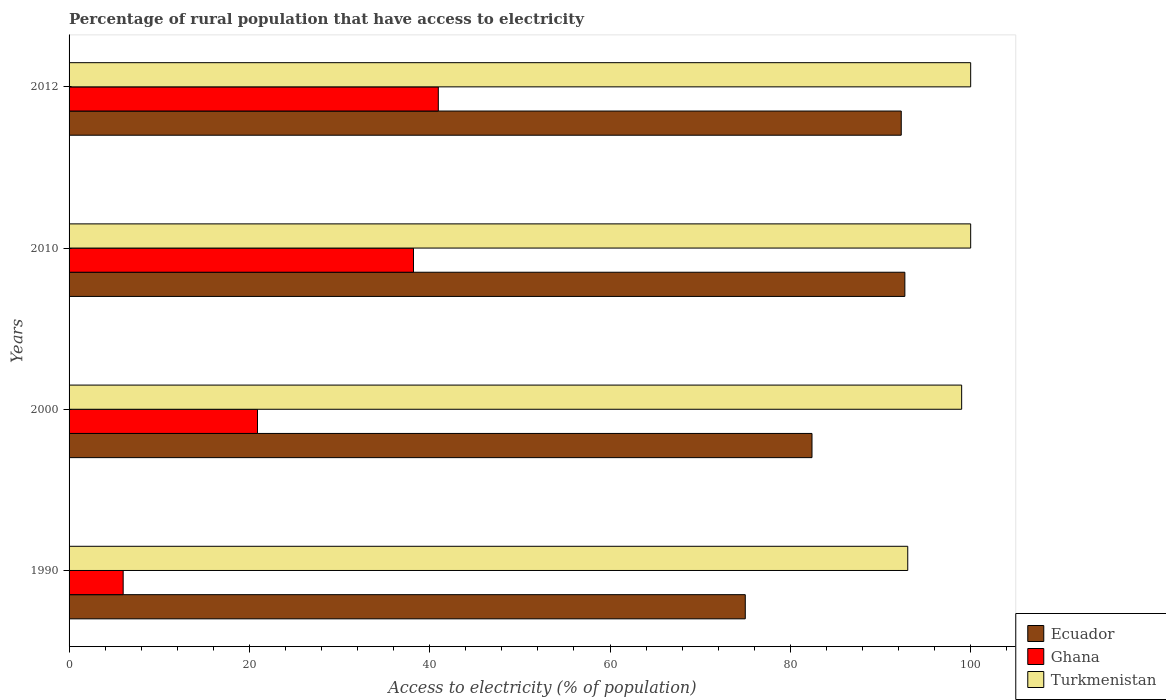How many different coloured bars are there?
Give a very brief answer. 3. How many groups of bars are there?
Provide a short and direct response. 4. Are the number of bars on each tick of the Y-axis equal?
Keep it short and to the point. Yes. What is the label of the 3rd group of bars from the top?
Give a very brief answer. 2000. In how many cases, is the number of bars for a given year not equal to the number of legend labels?
Your answer should be very brief. 0. What is the percentage of rural population that have access to electricity in Turkmenistan in 1990?
Offer a terse response. 93.02. Across all years, what is the maximum percentage of rural population that have access to electricity in Ghana?
Provide a short and direct response. 40.95. Across all years, what is the minimum percentage of rural population that have access to electricity in Ecuador?
Give a very brief answer. 75. In which year was the percentage of rural population that have access to electricity in Ghana maximum?
Provide a succinct answer. 2012. In which year was the percentage of rural population that have access to electricity in Turkmenistan minimum?
Your answer should be very brief. 1990. What is the total percentage of rural population that have access to electricity in Turkmenistan in the graph?
Your response must be concise. 392.02. What is the difference between the percentage of rural population that have access to electricity in Ghana in 2010 and that in 2012?
Provide a succinct answer. -2.75. What is the difference between the percentage of rural population that have access to electricity in Ghana in 2010 and the percentage of rural population that have access to electricity in Turkmenistan in 2012?
Your answer should be very brief. -61.8. What is the average percentage of rural population that have access to electricity in Ecuador per year?
Provide a succinct answer. 85.6. In the year 1990, what is the difference between the percentage of rural population that have access to electricity in Turkmenistan and percentage of rural population that have access to electricity in Ecuador?
Keep it short and to the point. 18.02. In how many years, is the percentage of rural population that have access to electricity in Ecuador greater than 88 %?
Your answer should be compact. 2. What is the ratio of the percentage of rural population that have access to electricity in Ghana in 2000 to that in 2010?
Provide a succinct answer. 0.55. Is the percentage of rural population that have access to electricity in Ghana in 1990 less than that in 2012?
Your response must be concise. Yes. What is the difference between the highest and the second highest percentage of rural population that have access to electricity in Ecuador?
Keep it short and to the point. 0.4. What is the difference between the highest and the lowest percentage of rural population that have access to electricity in Turkmenistan?
Keep it short and to the point. 6.98. Is the sum of the percentage of rural population that have access to electricity in Ecuador in 1990 and 2000 greater than the maximum percentage of rural population that have access to electricity in Turkmenistan across all years?
Offer a terse response. Yes. What does the 1st bar from the top in 2010 represents?
Your answer should be compact. Turkmenistan. What does the 2nd bar from the bottom in 2012 represents?
Your response must be concise. Ghana. Is it the case that in every year, the sum of the percentage of rural population that have access to electricity in Ghana and percentage of rural population that have access to electricity in Ecuador is greater than the percentage of rural population that have access to electricity in Turkmenistan?
Provide a succinct answer. No. How many bars are there?
Offer a terse response. 12. Are all the bars in the graph horizontal?
Keep it short and to the point. Yes. How many years are there in the graph?
Ensure brevity in your answer.  4. Are the values on the major ticks of X-axis written in scientific E-notation?
Your answer should be compact. No. Does the graph contain any zero values?
Ensure brevity in your answer.  No. How many legend labels are there?
Provide a short and direct response. 3. How are the legend labels stacked?
Offer a terse response. Vertical. What is the title of the graph?
Keep it short and to the point. Percentage of rural population that have access to electricity. Does "Bhutan" appear as one of the legend labels in the graph?
Provide a short and direct response. No. What is the label or title of the X-axis?
Offer a terse response. Access to electricity (% of population). What is the label or title of the Y-axis?
Your response must be concise. Years. What is the Access to electricity (% of population) of Ecuador in 1990?
Offer a very short reply. 75. What is the Access to electricity (% of population) of Ghana in 1990?
Offer a terse response. 6. What is the Access to electricity (% of population) of Turkmenistan in 1990?
Give a very brief answer. 93.02. What is the Access to electricity (% of population) of Ecuador in 2000?
Your answer should be very brief. 82.4. What is the Access to electricity (% of population) in Ghana in 2000?
Ensure brevity in your answer.  20.9. What is the Access to electricity (% of population) of Turkmenistan in 2000?
Your answer should be very brief. 99. What is the Access to electricity (% of population) in Ecuador in 2010?
Ensure brevity in your answer.  92.7. What is the Access to electricity (% of population) in Ghana in 2010?
Provide a short and direct response. 38.2. What is the Access to electricity (% of population) of Turkmenistan in 2010?
Give a very brief answer. 100. What is the Access to electricity (% of population) of Ecuador in 2012?
Provide a short and direct response. 92.3. What is the Access to electricity (% of population) in Ghana in 2012?
Provide a short and direct response. 40.95. What is the Access to electricity (% of population) of Turkmenistan in 2012?
Provide a succinct answer. 100. Across all years, what is the maximum Access to electricity (% of population) of Ecuador?
Ensure brevity in your answer.  92.7. Across all years, what is the maximum Access to electricity (% of population) in Ghana?
Keep it short and to the point. 40.95. Across all years, what is the maximum Access to electricity (% of population) of Turkmenistan?
Make the answer very short. 100. Across all years, what is the minimum Access to electricity (% of population) of Ghana?
Offer a very short reply. 6. Across all years, what is the minimum Access to electricity (% of population) in Turkmenistan?
Offer a very short reply. 93.02. What is the total Access to electricity (% of population) in Ecuador in the graph?
Provide a short and direct response. 342.4. What is the total Access to electricity (% of population) in Ghana in the graph?
Provide a succinct answer. 106.05. What is the total Access to electricity (% of population) in Turkmenistan in the graph?
Your answer should be compact. 392.02. What is the difference between the Access to electricity (% of population) of Ecuador in 1990 and that in 2000?
Make the answer very short. -7.4. What is the difference between the Access to electricity (% of population) of Ghana in 1990 and that in 2000?
Give a very brief answer. -14.9. What is the difference between the Access to electricity (% of population) in Turkmenistan in 1990 and that in 2000?
Give a very brief answer. -5.98. What is the difference between the Access to electricity (% of population) in Ecuador in 1990 and that in 2010?
Your answer should be compact. -17.7. What is the difference between the Access to electricity (% of population) in Ghana in 1990 and that in 2010?
Your response must be concise. -32.2. What is the difference between the Access to electricity (% of population) in Turkmenistan in 1990 and that in 2010?
Give a very brief answer. -6.98. What is the difference between the Access to electricity (% of population) of Ecuador in 1990 and that in 2012?
Keep it short and to the point. -17.3. What is the difference between the Access to electricity (% of population) in Ghana in 1990 and that in 2012?
Your answer should be very brief. -34.95. What is the difference between the Access to electricity (% of population) of Turkmenistan in 1990 and that in 2012?
Your answer should be compact. -6.98. What is the difference between the Access to electricity (% of population) in Ecuador in 2000 and that in 2010?
Your answer should be very brief. -10.3. What is the difference between the Access to electricity (% of population) of Ghana in 2000 and that in 2010?
Provide a succinct answer. -17.3. What is the difference between the Access to electricity (% of population) in Ghana in 2000 and that in 2012?
Make the answer very short. -20.05. What is the difference between the Access to electricity (% of population) in Ghana in 2010 and that in 2012?
Your answer should be very brief. -2.75. What is the difference between the Access to electricity (% of population) of Ecuador in 1990 and the Access to electricity (% of population) of Ghana in 2000?
Provide a succinct answer. 54.1. What is the difference between the Access to electricity (% of population) of Ghana in 1990 and the Access to electricity (% of population) of Turkmenistan in 2000?
Your answer should be compact. -93. What is the difference between the Access to electricity (% of population) in Ecuador in 1990 and the Access to electricity (% of population) in Ghana in 2010?
Your response must be concise. 36.8. What is the difference between the Access to electricity (% of population) in Ghana in 1990 and the Access to electricity (% of population) in Turkmenistan in 2010?
Keep it short and to the point. -94. What is the difference between the Access to electricity (% of population) of Ecuador in 1990 and the Access to electricity (% of population) of Ghana in 2012?
Offer a very short reply. 34.05. What is the difference between the Access to electricity (% of population) of Ghana in 1990 and the Access to electricity (% of population) of Turkmenistan in 2012?
Make the answer very short. -94. What is the difference between the Access to electricity (% of population) in Ecuador in 2000 and the Access to electricity (% of population) in Ghana in 2010?
Your response must be concise. 44.2. What is the difference between the Access to electricity (% of population) of Ecuador in 2000 and the Access to electricity (% of population) of Turkmenistan in 2010?
Make the answer very short. -17.6. What is the difference between the Access to electricity (% of population) of Ghana in 2000 and the Access to electricity (% of population) of Turkmenistan in 2010?
Your answer should be compact. -79.1. What is the difference between the Access to electricity (% of population) in Ecuador in 2000 and the Access to electricity (% of population) in Ghana in 2012?
Your answer should be very brief. 41.45. What is the difference between the Access to electricity (% of population) of Ecuador in 2000 and the Access to electricity (% of population) of Turkmenistan in 2012?
Offer a very short reply. -17.6. What is the difference between the Access to electricity (% of population) in Ghana in 2000 and the Access to electricity (% of population) in Turkmenistan in 2012?
Ensure brevity in your answer.  -79.1. What is the difference between the Access to electricity (% of population) in Ecuador in 2010 and the Access to electricity (% of population) in Ghana in 2012?
Your response must be concise. 51.75. What is the difference between the Access to electricity (% of population) in Ghana in 2010 and the Access to electricity (% of population) in Turkmenistan in 2012?
Provide a succinct answer. -61.8. What is the average Access to electricity (% of population) in Ecuador per year?
Your response must be concise. 85.6. What is the average Access to electricity (% of population) of Ghana per year?
Offer a very short reply. 26.51. What is the average Access to electricity (% of population) in Turkmenistan per year?
Keep it short and to the point. 98. In the year 1990, what is the difference between the Access to electricity (% of population) in Ecuador and Access to electricity (% of population) in Ghana?
Your response must be concise. 69. In the year 1990, what is the difference between the Access to electricity (% of population) of Ecuador and Access to electricity (% of population) of Turkmenistan?
Your answer should be very brief. -18.02. In the year 1990, what is the difference between the Access to electricity (% of population) of Ghana and Access to electricity (% of population) of Turkmenistan?
Provide a succinct answer. -87.02. In the year 2000, what is the difference between the Access to electricity (% of population) in Ecuador and Access to electricity (% of population) in Ghana?
Give a very brief answer. 61.5. In the year 2000, what is the difference between the Access to electricity (% of population) of Ecuador and Access to electricity (% of population) of Turkmenistan?
Give a very brief answer. -16.6. In the year 2000, what is the difference between the Access to electricity (% of population) of Ghana and Access to electricity (% of population) of Turkmenistan?
Offer a very short reply. -78.1. In the year 2010, what is the difference between the Access to electricity (% of population) in Ecuador and Access to electricity (% of population) in Ghana?
Ensure brevity in your answer.  54.5. In the year 2010, what is the difference between the Access to electricity (% of population) in Ghana and Access to electricity (% of population) in Turkmenistan?
Provide a succinct answer. -61.8. In the year 2012, what is the difference between the Access to electricity (% of population) of Ecuador and Access to electricity (% of population) of Ghana?
Your answer should be compact. 51.35. In the year 2012, what is the difference between the Access to electricity (% of population) in Ghana and Access to electricity (% of population) in Turkmenistan?
Your answer should be compact. -59.05. What is the ratio of the Access to electricity (% of population) of Ecuador in 1990 to that in 2000?
Provide a short and direct response. 0.91. What is the ratio of the Access to electricity (% of population) of Ghana in 1990 to that in 2000?
Provide a succinct answer. 0.29. What is the ratio of the Access to electricity (% of population) of Turkmenistan in 1990 to that in 2000?
Offer a terse response. 0.94. What is the ratio of the Access to electricity (% of population) of Ecuador in 1990 to that in 2010?
Give a very brief answer. 0.81. What is the ratio of the Access to electricity (% of population) in Ghana in 1990 to that in 2010?
Provide a short and direct response. 0.16. What is the ratio of the Access to electricity (% of population) in Turkmenistan in 1990 to that in 2010?
Your answer should be very brief. 0.93. What is the ratio of the Access to electricity (% of population) of Ecuador in 1990 to that in 2012?
Your answer should be compact. 0.81. What is the ratio of the Access to electricity (% of population) of Ghana in 1990 to that in 2012?
Give a very brief answer. 0.15. What is the ratio of the Access to electricity (% of population) of Turkmenistan in 1990 to that in 2012?
Give a very brief answer. 0.93. What is the ratio of the Access to electricity (% of population) in Ghana in 2000 to that in 2010?
Make the answer very short. 0.55. What is the ratio of the Access to electricity (% of population) of Turkmenistan in 2000 to that in 2010?
Your answer should be very brief. 0.99. What is the ratio of the Access to electricity (% of population) in Ecuador in 2000 to that in 2012?
Your response must be concise. 0.89. What is the ratio of the Access to electricity (% of population) of Ghana in 2000 to that in 2012?
Ensure brevity in your answer.  0.51. What is the ratio of the Access to electricity (% of population) in Turkmenistan in 2000 to that in 2012?
Ensure brevity in your answer.  0.99. What is the ratio of the Access to electricity (% of population) of Ecuador in 2010 to that in 2012?
Provide a short and direct response. 1. What is the ratio of the Access to electricity (% of population) in Ghana in 2010 to that in 2012?
Your response must be concise. 0.93. What is the difference between the highest and the second highest Access to electricity (% of population) in Ecuador?
Your answer should be compact. 0.4. What is the difference between the highest and the second highest Access to electricity (% of population) in Ghana?
Ensure brevity in your answer.  2.75. What is the difference between the highest and the second highest Access to electricity (% of population) of Turkmenistan?
Offer a very short reply. 0. What is the difference between the highest and the lowest Access to electricity (% of population) in Ghana?
Provide a succinct answer. 34.95. What is the difference between the highest and the lowest Access to electricity (% of population) of Turkmenistan?
Ensure brevity in your answer.  6.98. 